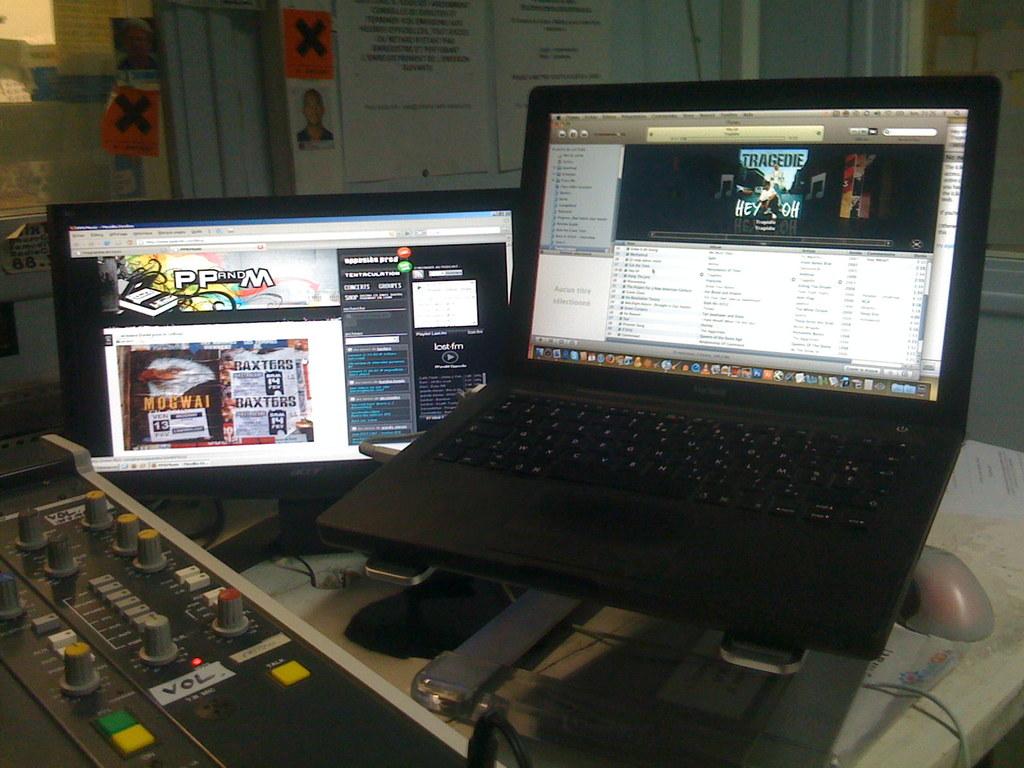What is on the screen on the right?
Provide a short and direct response. Itunes. What are the letters on the machine on the left under the knob?
Give a very brief answer. Vol. 